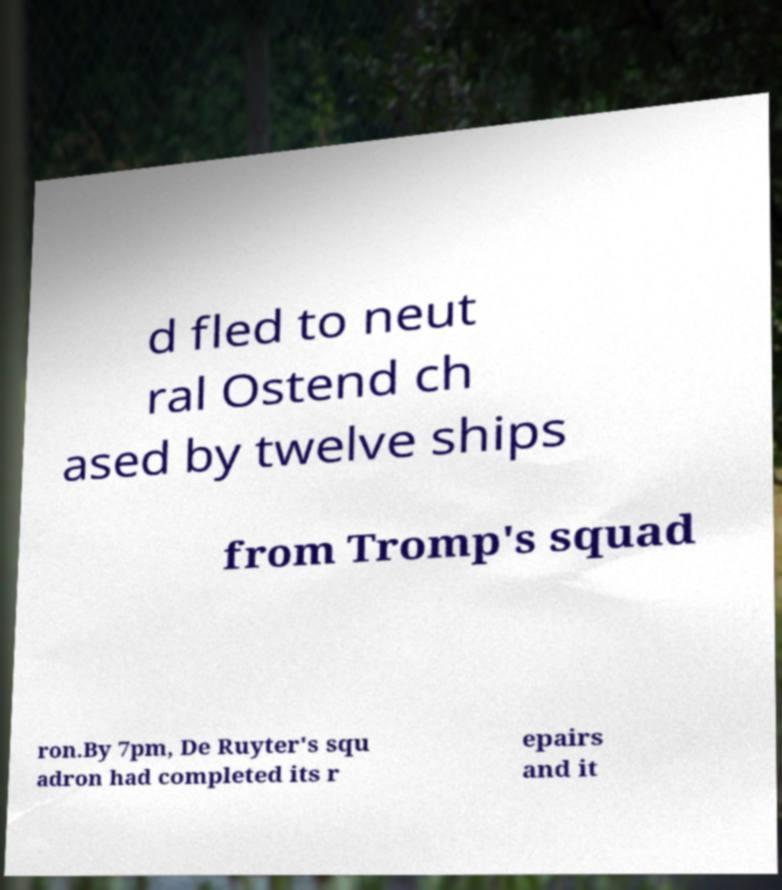Can you read and provide the text displayed in the image?This photo seems to have some interesting text. Can you extract and type it out for me? d fled to neut ral Ostend ch ased by twelve ships from Tromp's squad ron.By 7pm, De Ruyter's squ adron had completed its r epairs and it 